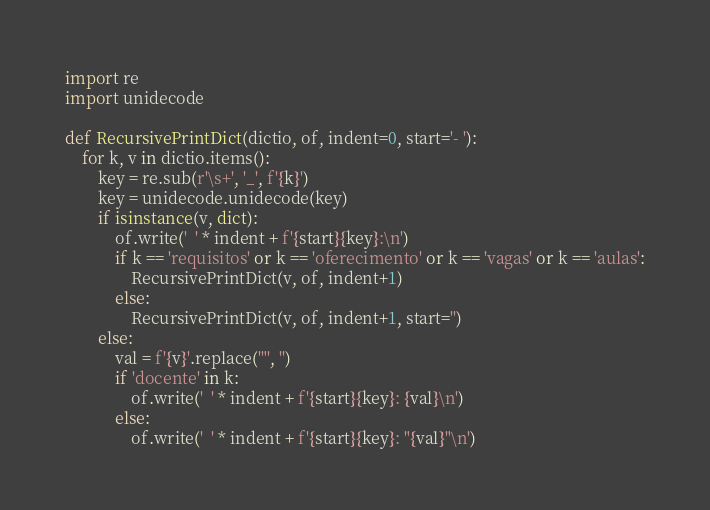Convert code to text. <code><loc_0><loc_0><loc_500><loc_500><_Python_>import re
import unidecode

def RecursivePrintDict(dictio, of, indent=0, start='- '):
    for k, v in dictio.items():
        key = re.sub(r'\s+', '_', f'{k}')
        key = unidecode.unidecode(key)
        if isinstance(v, dict):
            of.write('  ' * indent + f'{start}{key}:\n')
            if k == 'requisitos' or k == 'oferecimento' or k == 'vagas' or k == 'aulas':
                RecursivePrintDict(v, of, indent+1)
            else:
                RecursivePrintDict(v, of, indent+1, start='')
        else:
            val = f'{v}'.replace('"', '')
            if 'docente' in k:
                of.write('  ' * indent + f'{start}{key}: {val}\n')
            else:
                of.write('  ' * indent + f'{start}{key}: "{val}"\n')</code> 